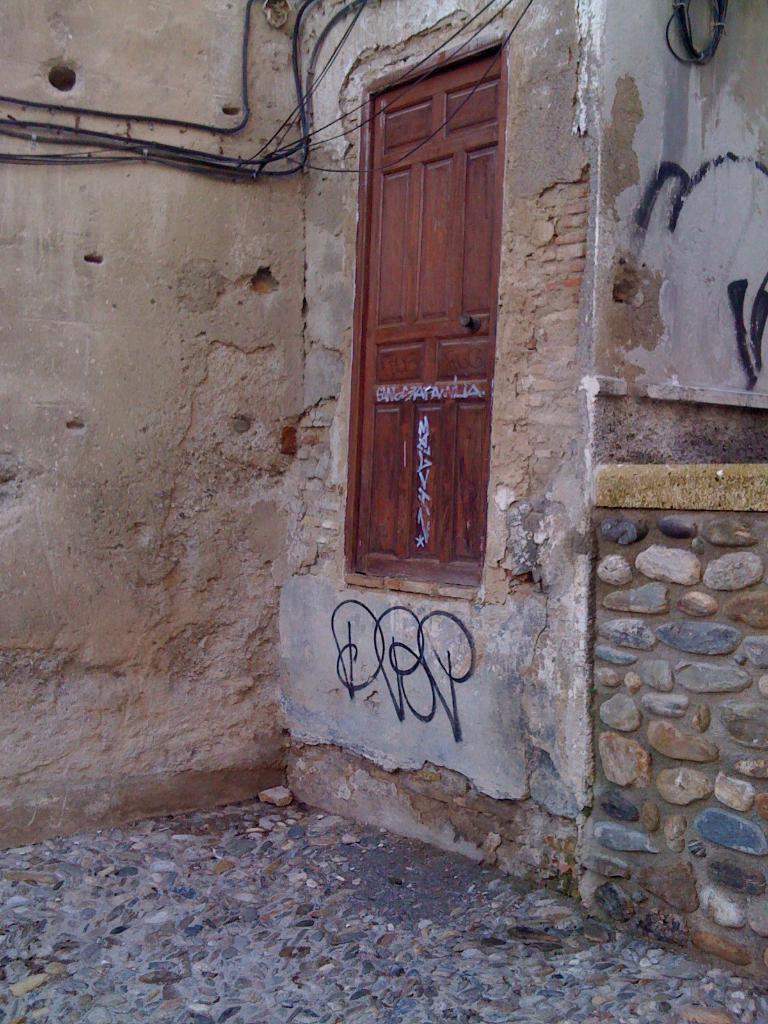How would you summarize this image in a sentence or two? In this image there is a wall, there is a window, there is text on the wall, there are wires on the wall, there is ground towards the bottom of the image, there is a stone on the ground, there is a wire towards the top of the image. 